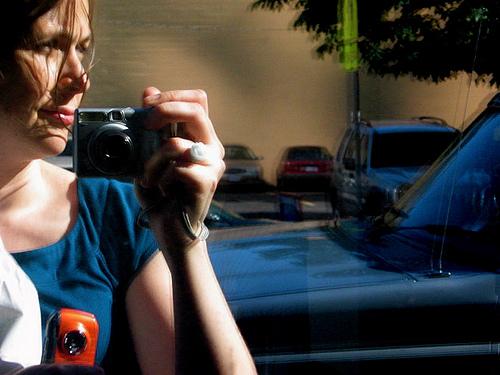What is she taking a picture of?
Give a very brief answer. Car. Is the person facing the same direction as her camera is pointed?
Short answer required. No. How tall is the woman?
Write a very short answer. 5'5". Who is taking a picture?
Be succinct. Woman. Is she at home?
Write a very short answer. No. Is she wearing a ring?
Quick response, please. Yes. What is the orange thing in front of the woman?
Give a very brief answer. Camera. What color is the color?
Short answer required. Blue. What type of vehicle is in the background?
Be succinct. Car. What vehicle are the women standing next to?
Answer briefly. Truck. 